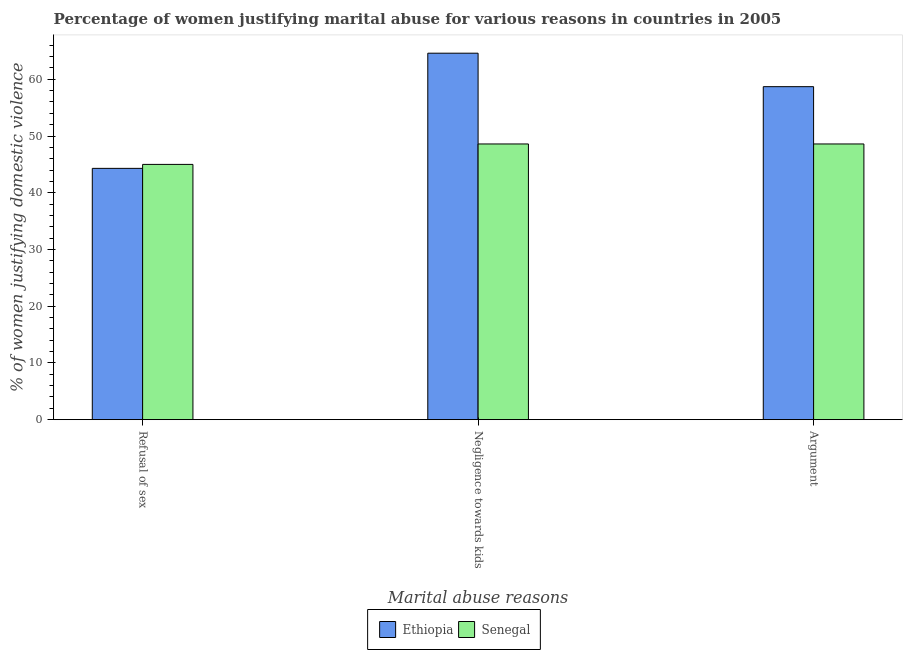How many different coloured bars are there?
Keep it short and to the point. 2. Are the number of bars per tick equal to the number of legend labels?
Keep it short and to the point. Yes. How many bars are there on the 1st tick from the left?
Your answer should be very brief. 2. How many bars are there on the 2nd tick from the right?
Offer a terse response. 2. What is the label of the 2nd group of bars from the left?
Your response must be concise. Negligence towards kids. What is the percentage of women justifying domestic violence due to refusal of sex in Senegal?
Keep it short and to the point. 45. Across all countries, what is the minimum percentage of women justifying domestic violence due to negligence towards kids?
Offer a terse response. 48.6. In which country was the percentage of women justifying domestic violence due to negligence towards kids maximum?
Offer a terse response. Ethiopia. In which country was the percentage of women justifying domestic violence due to arguments minimum?
Make the answer very short. Senegal. What is the total percentage of women justifying domestic violence due to arguments in the graph?
Keep it short and to the point. 107.3. What is the difference between the percentage of women justifying domestic violence due to refusal of sex in Senegal and that in Ethiopia?
Provide a succinct answer. 0.7. What is the difference between the percentage of women justifying domestic violence due to refusal of sex in Ethiopia and the percentage of women justifying domestic violence due to arguments in Senegal?
Offer a very short reply. -4.3. What is the average percentage of women justifying domestic violence due to arguments per country?
Make the answer very short. 53.65. What is the difference between the percentage of women justifying domestic violence due to refusal of sex and percentage of women justifying domestic violence due to arguments in Ethiopia?
Make the answer very short. -14.4. In how many countries, is the percentage of women justifying domestic violence due to arguments greater than 52 %?
Provide a succinct answer. 1. What is the ratio of the percentage of women justifying domestic violence due to arguments in Senegal to that in Ethiopia?
Your answer should be compact. 0.83. Is the percentage of women justifying domestic violence due to arguments in Ethiopia less than that in Senegal?
Make the answer very short. No. Is the difference between the percentage of women justifying domestic violence due to negligence towards kids in Ethiopia and Senegal greater than the difference between the percentage of women justifying domestic violence due to arguments in Ethiopia and Senegal?
Make the answer very short. Yes. What is the difference between the highest and the second highest percentage of women justifying domestic violence due to negligence towards kids?
Provide a short and direct response. 16. What is the difference between the highest and the lowest percentage of women justifying domestic violence due to arguments?
Offer a terse response. 10.1. What does the 2nd bar from the left in Negligence towards kids represents?
Make the answer very short. Senegal. What does the 2nd bar from the right in Refusal of sex represents?
Provide a short and direct response. Ethiopia. How many bars are there?
Offer a terse response. 6. What is the difference between two consecutive major ticks on the Y-axis?
Make the answer very short. 10. Does the graph contain any zero values?
Ensure brevity in your answer.  No. Where does the legend appear in the graph?
Provide a succinct answer. Bottom center. How many legend labels are there?
Provide a succinct answer. 2. How are the legend labels stacked?
Your response must be concise. Horizontal. What is the title of the graph?
Your response must be concise. Percentage of women justifying marital abuse for various reasons in countries in 2005. Does "Estonia" appear as one of the legend labels in the graph?
Make the answer very short. No. What is the label or title of the X-axis?
Your answer should be compact. Marital abuse reasons. What is the label or title of the Y-axis?
Offer a very short reply. % of women justifying domestic violence. What is the % of women justifying domestic violence in Ethiopia in Refusal of sex?
Offer a very short reply. 44.3. What is the % of women justifying domestic violence of Senegal in Refusal of sex?
Make the answer very short. 45. What is the % of women justifying domestic violence of Ethiopia in Negligence towards kids?
Your answer should be very brief. 64.6. What is the % of women justifying domestic violence in Senegal in Negligence towards kids?
Your answer should be very brief. 48.6. What is the % of women justifying domestic violence in Ethiopia in Argument?
Keep it short and to the point. 58.7. What is the % of women justifying domestic violence in Senegal in Argument?
Your response must be concise. 48.6. Across all Marital abuse reasons, what is the maximum % of women justifying domestic violence in Ethiopia?
Make the answer very short. 64.6. Across all Marital abuse reasons, what is the maximum % of women justifying domestic violence in Senegal?
Ensure brevity in your answer.  48.6. Across all Marital abuse reasons, what is the minimum % of women justifying domestic violence in Ethiopia?
Offer a terse response. 44.3. Across all Marital abuse reasons, what is the minimum % of women justifying domestic violence in Senegal?
Your answer should be compact. 45. What is the total % of women justifying domestic violence in Ethiopia in the graph?
Keep it short and to the point. 167.6. What is the total % of women justifying domestic violence in Senegal in the graph?
Offer a terse response. 142.2. What is the difference between the % of women justifying domestic violence in Ethiopia in Refusal of sex and that in Negligence towards kids?
Provide a short and direct response. -20.3. What is the difference between the % of women justifying domestic violence in Senegal in Refusal of sex and that in Negligence towards kids?
Your response must be concise. -3.6. What is the difference between the % of women justifying domestic violence of Ethiopia in Refusal of sex and that in Argument?
Provide a short and direct response. -14.4. What is the difference between the % of women justifying domestic violence in Senegal in Refusal of sex and that in Argument?
Give a very brief answer. -3.6. What is the difference between the % of women justifying domestic violence of Ethiopia in Negligence towards kids and that in Argument?
Provide a succinct answer. 5.9. What is the difference between the % of women justifying domestic violence of Senegal in Negligence towards kids and that in Argument?
Your answer should be very brief. 0. What is the difference between the % of women justifying domestic violence in Ethiopia in Refusal of sex and the % of women justifying domestic violence in Senegal in Argument?
Your response must be concise. -4.3. What is the average % of women justifying domestic violence of Ethiopia per Marital abuse reasons?
Provide a succinct answer. 55.87. What is the average % of women justifying domestic violence of Senegal per Marital abuse reasons?
Provide a short and direct response. 47.4. What is the difference between the % of women justifying domestic violence in Ethiopia and % of women justifying domestic violence in Senegal in Refusal of sex?
Give a very brief answer. -0.7. What is the difference between the % of women justifying domestic violence of Ethiopia and % of women justifying domestic violence of Senegal in Negligence towards kids?
Offer a terse response. 16. What is the ratio of the % of women justifying domestic violence of Ethiopia in Refusal of sex to that in Negligence towards kids?
Make the answer very short. 0.69. What is the ratio of the % of women justifying domestic violence of Senegal in Refusal of sex to that in Negligence towards kids?
Give a very brief answer. 0.93. What is the ratio of the % of women justifying domestic violence of Ethiopia in Refusal of sex to that in Argument?
Your answer should be very brief. 0.75. What is the ratio of the % of women justifying domestic violence of Senegal in Refusal of sex to that in Argument?
Provide a succinct answer. 0.93. What is the ratio of the % of women justifying domestic violence of Ethiopia in Negligence towards kids to that in Argument?
Your response must be concise. 1.1. What is the ratio of the % of women justifying domestic violence in Senegal in Negligence towards kids to that in Argument?
Offer a terse response. 1. What is the difference between the highest and the lowest % of women justifying domestic violence of Ethiopia?
Your response must be concise. 20.3. 